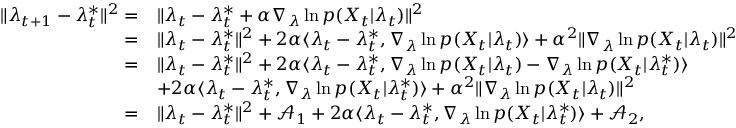<formula> <loc_0><loc_0><loc_500><loc_500>\begin{array} { r l } { \| \lambda _ { t + 1 } - \lambda _ { t } ^ { * } \| ^ { 2 } = } & { \| \lambda _ { t } - \lambda _ { t } ^ { * } + \alpha \nabla _ { \lambda } \ln p ( X _ { t } | \lambda _ { t } ) \| ^ { 2 } } \\ { = } & { \| \lambda _ { t } - \lambda _ { t } ^ { * } \| ^ { 2 } + 2 \alpha \langle \lambda _ { t } - \lambda _ { t } ^ { * } , \nabla _ { \lambda } \ln p ( X _ { t } | \lambda _ { t } ) \rangle + \alpha ^ { 2 } \| \nabla _ { \lambda } \ln p ( X _ { t } | \lambda _ { t } ) \| ^ { 2 } } \\ { = } & { \| \lambda _ { t } - \lambda _ { t } ^ { * } \| ^ { 2 } + 2 \alpha \langle \lambda _ { t } - \lambda _ { t } ^ { * } , \nabla _ { \lambda } \ln p ( X _ { t } | \lambda _ { t } ) - \nabla _ { \lambda } \ln p ( X _ { t } | \lambda _ { t } ^ { * } ) \rangle } \\ & { + 2 \alpha \langle \lambda _ { t } - \lambda _ { t } ^ { * } , \nabla _ { \lambda } \ln p ( X _ { t } | \lambda _ { t } ^ { * } ) \rangle + \alpha ^ { 2 } \| \nabla _ { \lambda } \ln p ( X _ { t } | \lambda _ { t } ) \| ^ { 2 } } \\ { = } & { \| \lambda _ { t } - \lambda _ { t } ^ { * } \| ^ { 2 } + \mathcal { A } _ { 1 } + 2 \alpha \langle \lambda _ { t } - \lambda _ { t } ^ { * } , \nabla _ { \lambda } \ln p ( X _ { t } | \lambda _ { t } ^ { * } ) \rangle + \mathcal { A } _ { 2 } , } \end{array}</formula> 